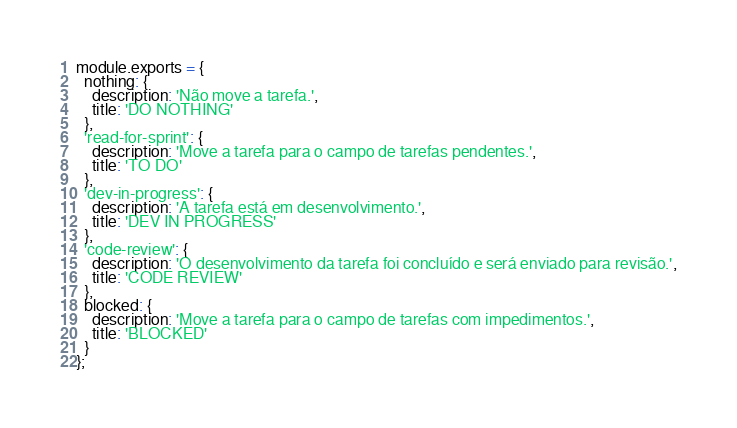Convert code to text. <code><loc_0><loc_0><loc_500><loc_500><_JavaScript_>module.exports = {
  nothing: {
    description: 'Não move a tarefa.',
    title: 'DO NOTHING'
  },
  'read-for-sprint': {
    description: 'Move a tarefa para o campo de tarefas pendentes.',
    title: 'TO DO'
  },
  'dev-in-progress': {
    description: 'A tarefa está em desenvolvimento.',
    title: 'DEV IN PROGRESS'
  },
  'code-review': {
    description: 'O desenvolvimento da tarefa foi concluído e será enviado para revisão.',
    title: 'CODE REVIEW'
  },
  blocked: {
    description: 'Move a tarefa para o campo de tarefas com impedimentos.',
    title: 'BLOCKED'
  }
};
</code> 